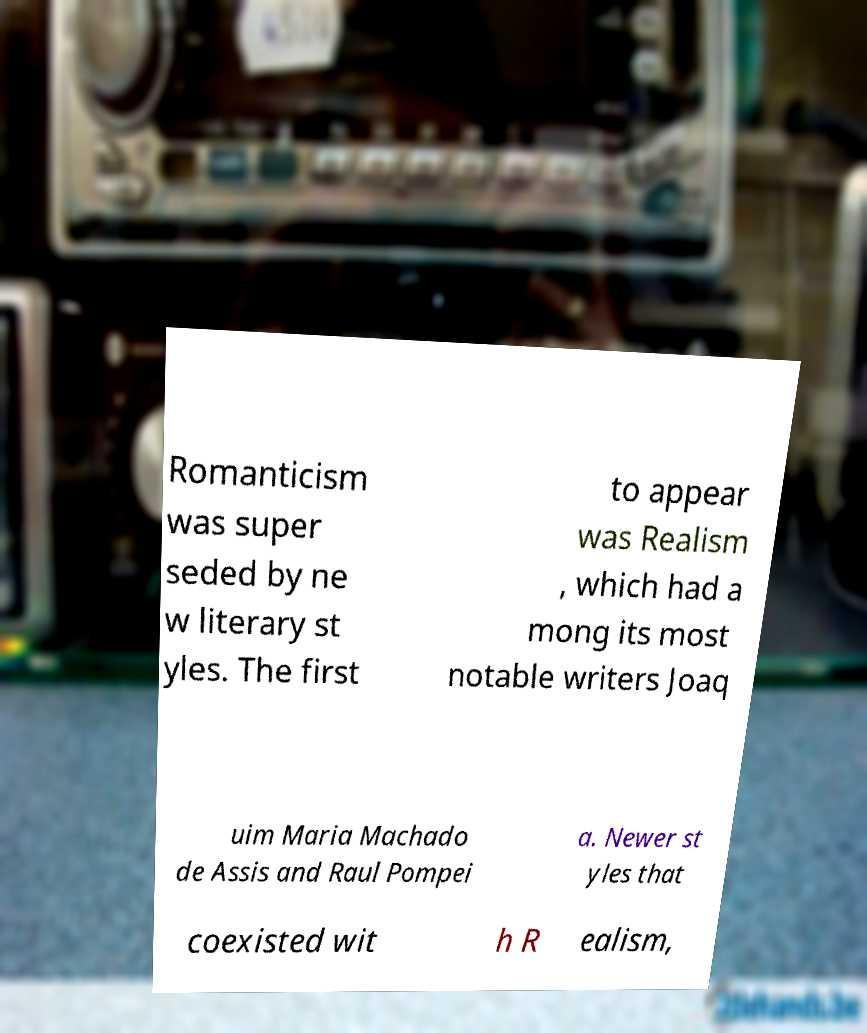Please identify and transcribe the text found in this image. Romanticism was super seded by ne w literary st yles. The first to appear was Realism , which had a mong its most notable writers Joaq uim Maria Machado de Assis and Raul Pompei a. Newer st yles that coexisted wit h R ealism, 